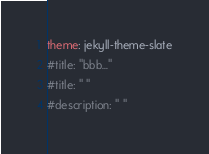<code> <loc_0><loc_0><loc_500><loc_500><_YAML_>theme: jekyll-theme-slate
#title: "bbb..."
#title: " "
#description: " "
</code> 